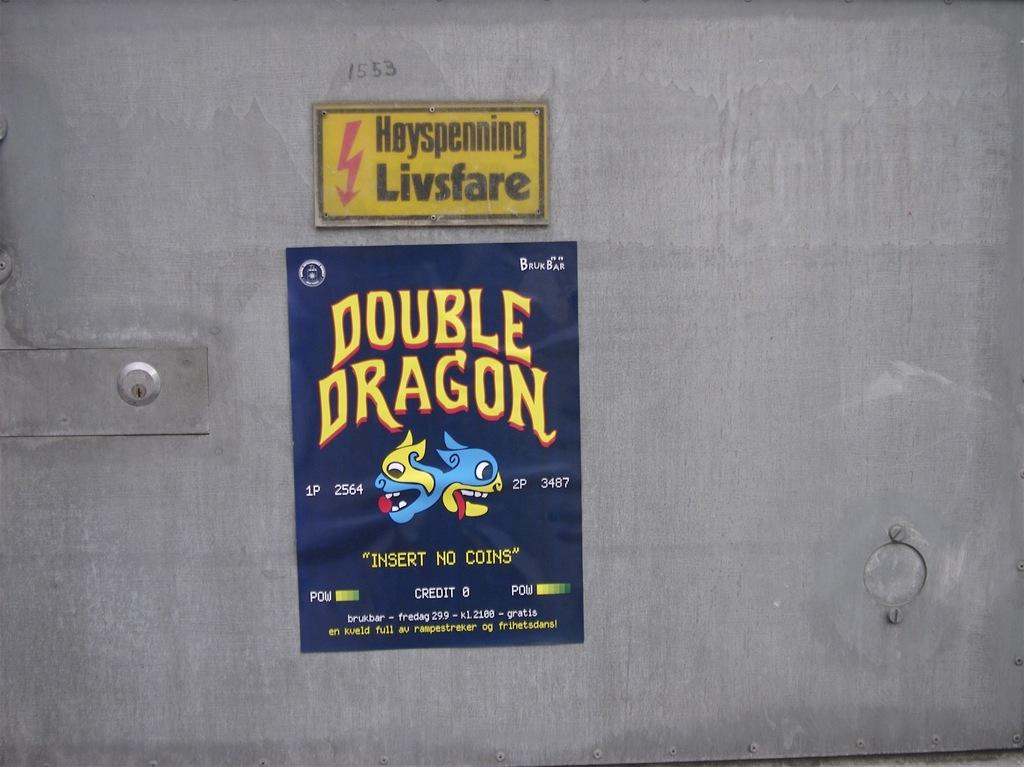<image>
Share a concise interpretation of the image provided. double dragon sticker is stuck onto the wall 